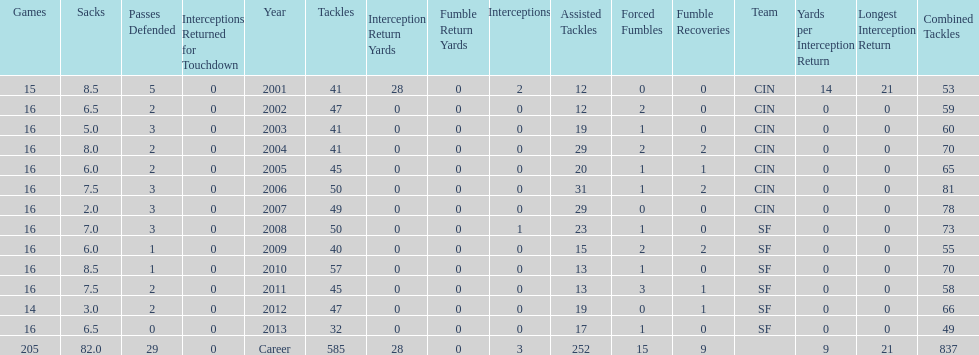How many fumble recoveries did this player have in 2004? 2. 